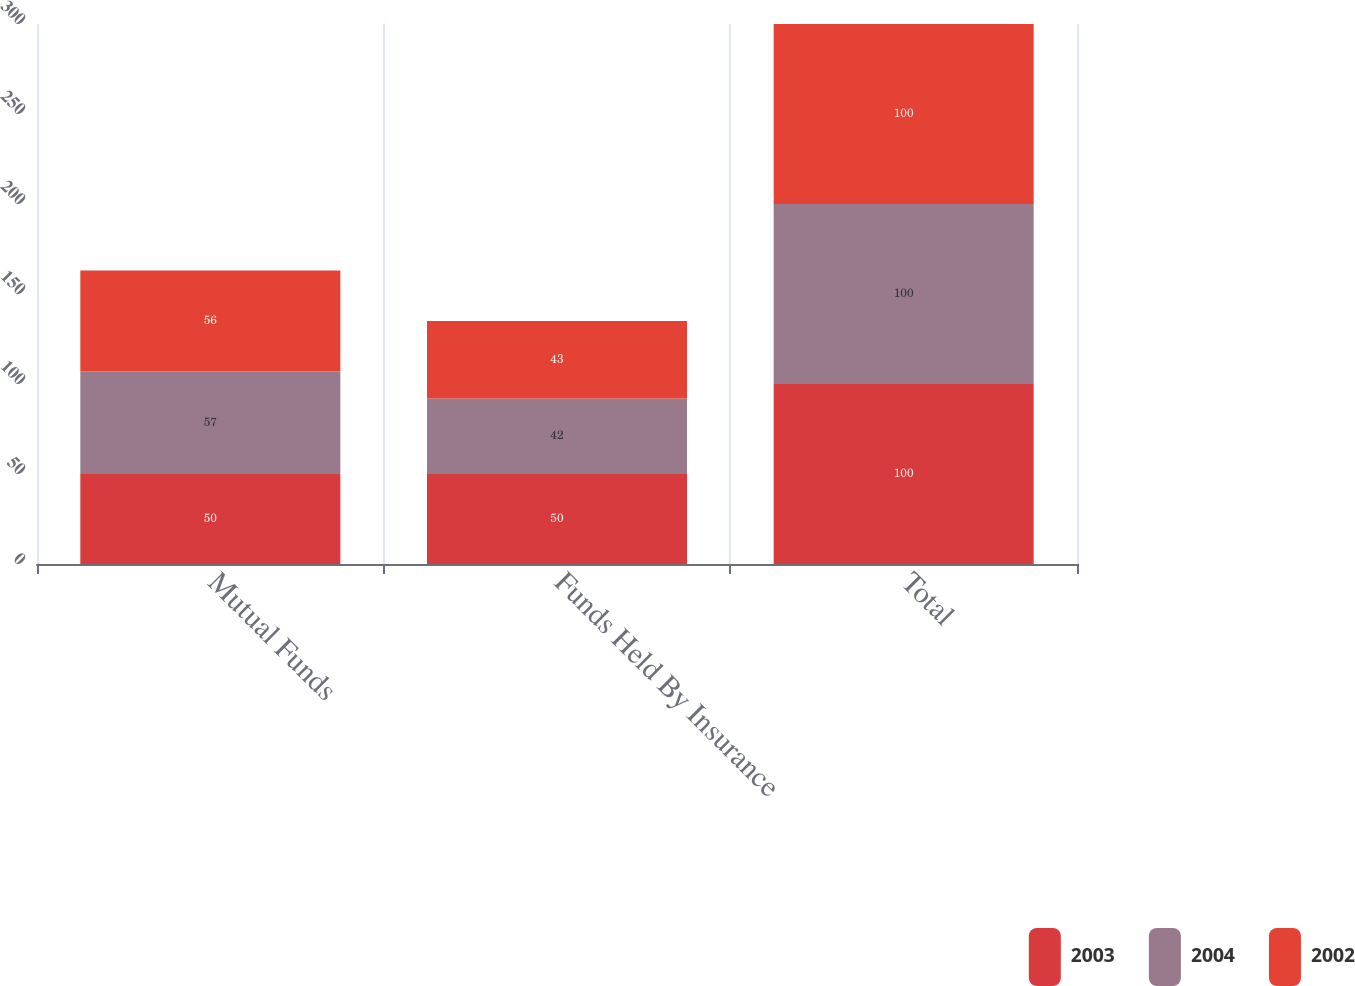Convert chart. <chart><loc_0><loc_0><loc_500><loc_500><stacked_bar_chart><ecel><fcel>Mutual Funds<fcel>Funds Held By Insurance<fcel>Total<nl><fcel>2003<fcel>50<fcel>50<fcel>100<nl><fcel>2004<fcel>57<fcel>42<fcel>100<nl><fcel>2002<fcel>56<fcel>43<fcel>100<nl></chart> 